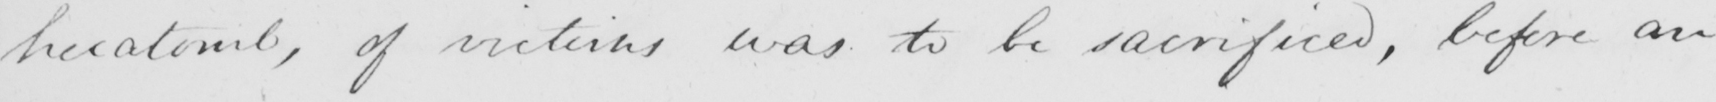What text is written in this handwritten line? hecatomb , of victims was to be sacrificed , before an 